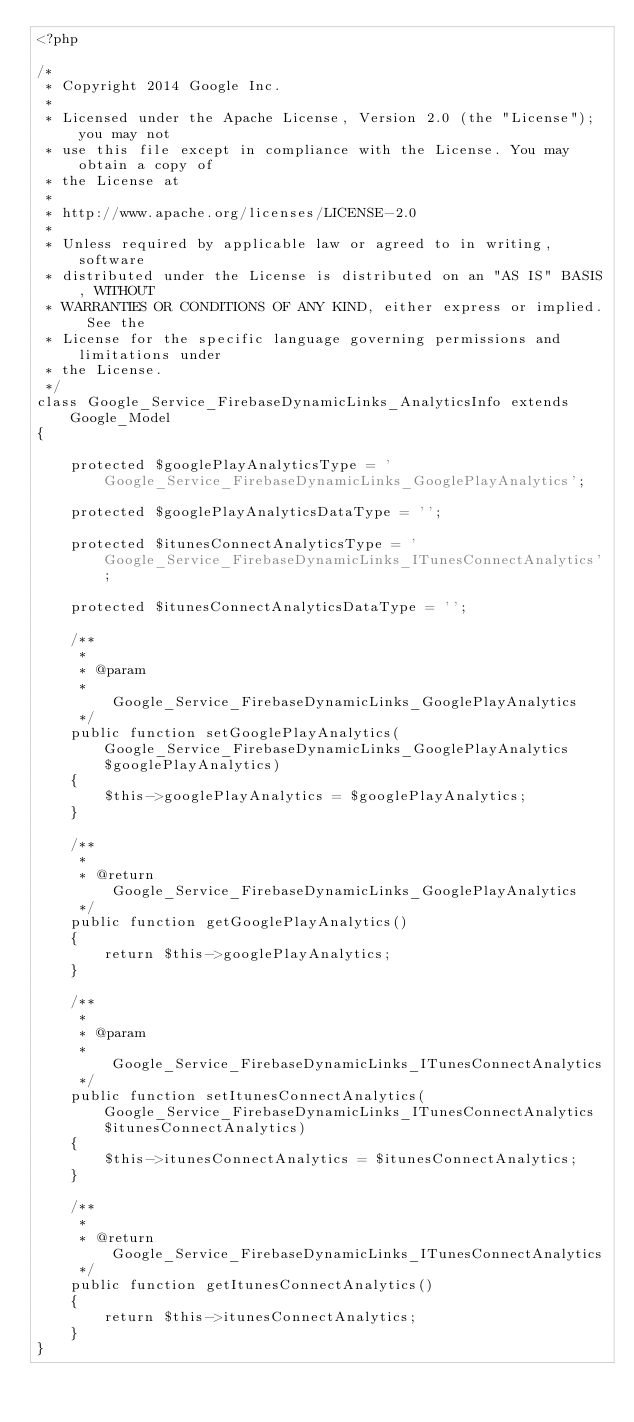<code> <loc_0><loc_0><loc_500><loc_500><_PHP_><?php

/*
 * Copyright 2014 Google Inc.
 *
 * Licensed under the Apache License, Version 2.0 (the "License"); you may not
 * use this file except in compliance with the License. You may obtain a copy of
 * the License at
 *
 * http://www.apache.org/licenses/LICENSE-2.0
 *
 * Unless required by applicable law or agreed to in writing, software
 * distributed under the License is distributed on an "AS IS" BASIS, WITHOUT
 * WARRANTIES OR CONDITIONS OF ANY KIND, either express or implied. See the
 * License for the specific language governing permissions and limitations under
 * the License.
 */
class Google_Service_FirebaseDynamicLinks_AnalyticsInfo extends Google_Model
{

    protected $googlePlayAnalyticsType = 'Google_Service_FirebaseDynamicLinks_GooglePlayAnalytics';

    protected $googlePlayAnalyticsDataType = '';

    protected $itunesConnectAnalyticsType = 'Google_Service_FirebaseDynamicLinks_ITunesConnectAnalytics';

    protected $itunesConnectAnalyticsDataType = '';

    /**
     *
     * @param
     *            Google_Service_FirebaseDynamicLinks_GooglePlayAnalytics
     */
    public function setGooglePlayAnalytics(Google_Service_FirebaseDynamicLinks_GooglePlayAnalytics $googlePlayAnalytics)
    {
        $this->googlePlayAnalytics = $googlePlayAnalytics;
    }

    /**
     *
     * @return Google_Service_FirebaseDynamicLinks_GooglePlayAnalytics
     */
    public function getGooglePlayAnalytics()
    {
        return $this->googlePlayAnalytics;
    }

    /**
     *
     * @param
     *            Google_Service_FirebaseDynamicLinks_ITunesConnectAnalytics
     */
    public function setItunesConnectAnalytics(Google_Service_FirebaseDynamicLinks_ITunesConnectAnalytics $itunesConnectAnalytics)
    {
        $this->itunesConnectAnalytics = $itunesConnectAnalytics;
    }

    /**
     *
     * @return Google_Service_FirebaseDynamicLinks_ITunesConnectAnalytics
     */
    public function getItunesConnectAnalytics()
    {
        return $this->itunesConnectAnalytics;
    }
}
</code> 